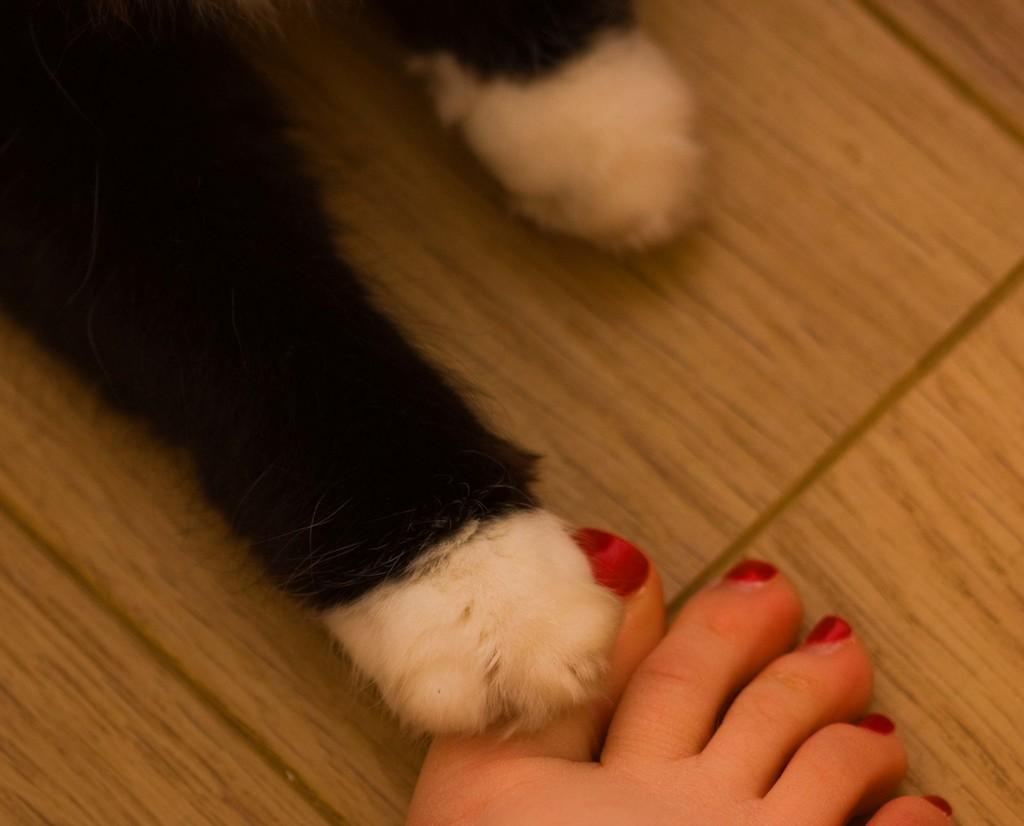What body part of a person is visible at the bottom of the image? One person's leg is visible at the bottom of the image. What type of legs are also visible in the image? Animal legs are visible in the image. What surface can be seen in the background of the image? There is a floor visible in the background of the image. What type of kitty can be seen playing with a creature in the image? There is no kitty or creature present in the image; only a person's leg and animal legs are visible. 